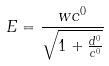Convert formula to latex. <formula><loc_0><loc_0><loc_500><loc_500>E = \frac { w c ^ { 0 } } { \sqrt { 1 + \frac { d ^ { 0 } } { c ^ { 0 } } } }</formula> 